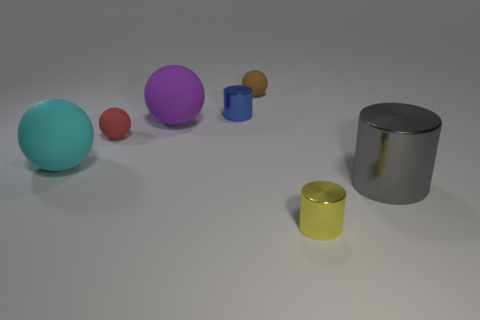How many things are both behind the large gray metallic object and in front of the purple sphere?
Your answer should be very brief. 2. What number of things are large brown cylinders or small matte balls to the right of the red sphere?
Ensure brevity in your answer.  1. Are there more yellow metal cylinders than small cubes?
Ensure brevity in your answer.  Yes. What shape is the small metal thing in front of the cyan matte thing?
Keep it short and to the point. Cylinder. What number of gray objects have the same shape as the tiny blue thing?
Ensure brevity in your answer.  1. There is a shiny cylinder to the left of the small shiny cylinder in front of the small blue cylinder; what size is it?
Provide a short and direct response. Small. What number of green things are either small objects or small shiny cylinders?
Provide a short and direct response. 0. Is the number of yellow cylinders to the right of the cyan matte thing less than the number of metal objects left of the gray object?
Keep it short and to the point. Yes. There is a cyan matte thing; is it the same size as the purple rubber object that is to the right of the red matte sphere?
Give a very brief answer. Yes. How many brown objects have the same size as the blue thing?
Offer a very short reply. 1. 